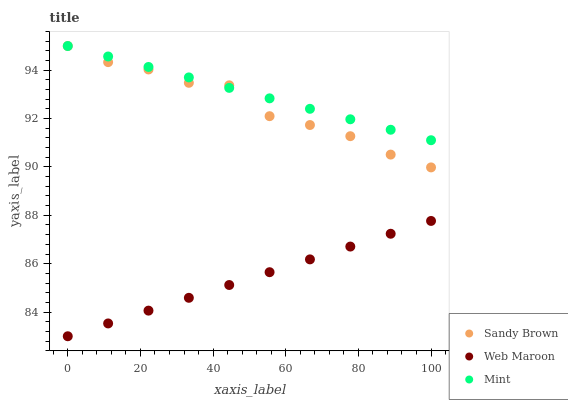Does Web Maroon have the minimum area under the curve?
Answer yes or no. Yes. Does Mint have the maximum area under the curve?
Answer yes or no. Yes. Does Sandy Brown have the minimum area under the curve?
Answer yes or no. No. Does Sandy Brown have the maximum area under the curve?
Answer yes or no. No. Is Mint the smoothest?
Answer yes or no. Yes. Is Sandy Brown the roughest?
Answer yes or no. Yes. Is Sandy Brown the smoothest?
Answer yes or no. No. Is Mint the roughest?
Answer yes or no. No. Does Web Maroon have the lowest value?
Answer yes or no. Yes. Does Sandy Brown have the lowest value?
Answer yes or no. No. Does Mint have the highest value?
Answer yes or no. Yes. Is Web Maroon less than Mint?
Answer yes or no. Yes. Is Sandy Brown greater than Web Maroon?
Answer yes or no. Yes. Does Mint intersect Sandy Brown?
Answer yes or no. Yes. Is Mint less than Sandy Brown?
Answer yes or no. No. Is Mint greater than Sandy Brown?
Answer yes or no. No. Does Web Maroon intersect Mint?
Answer yes or no. No. 